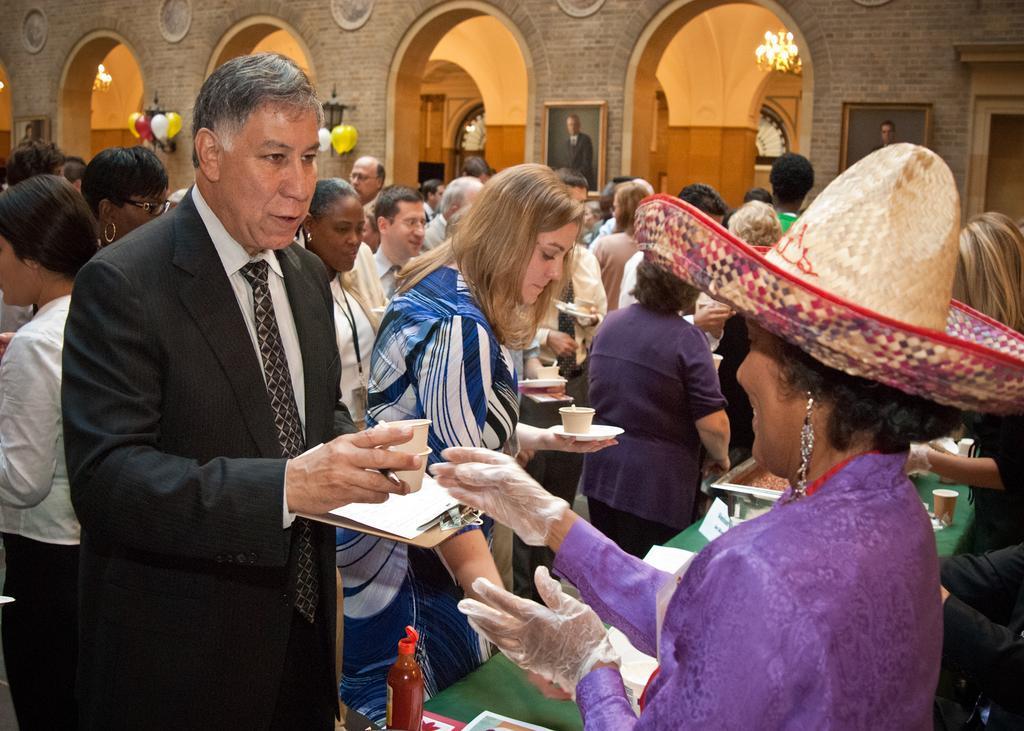How would you summarize this image in a sentence or two? In this picture I can see a woman on the right side, in the middle few people are taking the food cups, in the background there are balloons, lights and photo frames on the wall. 